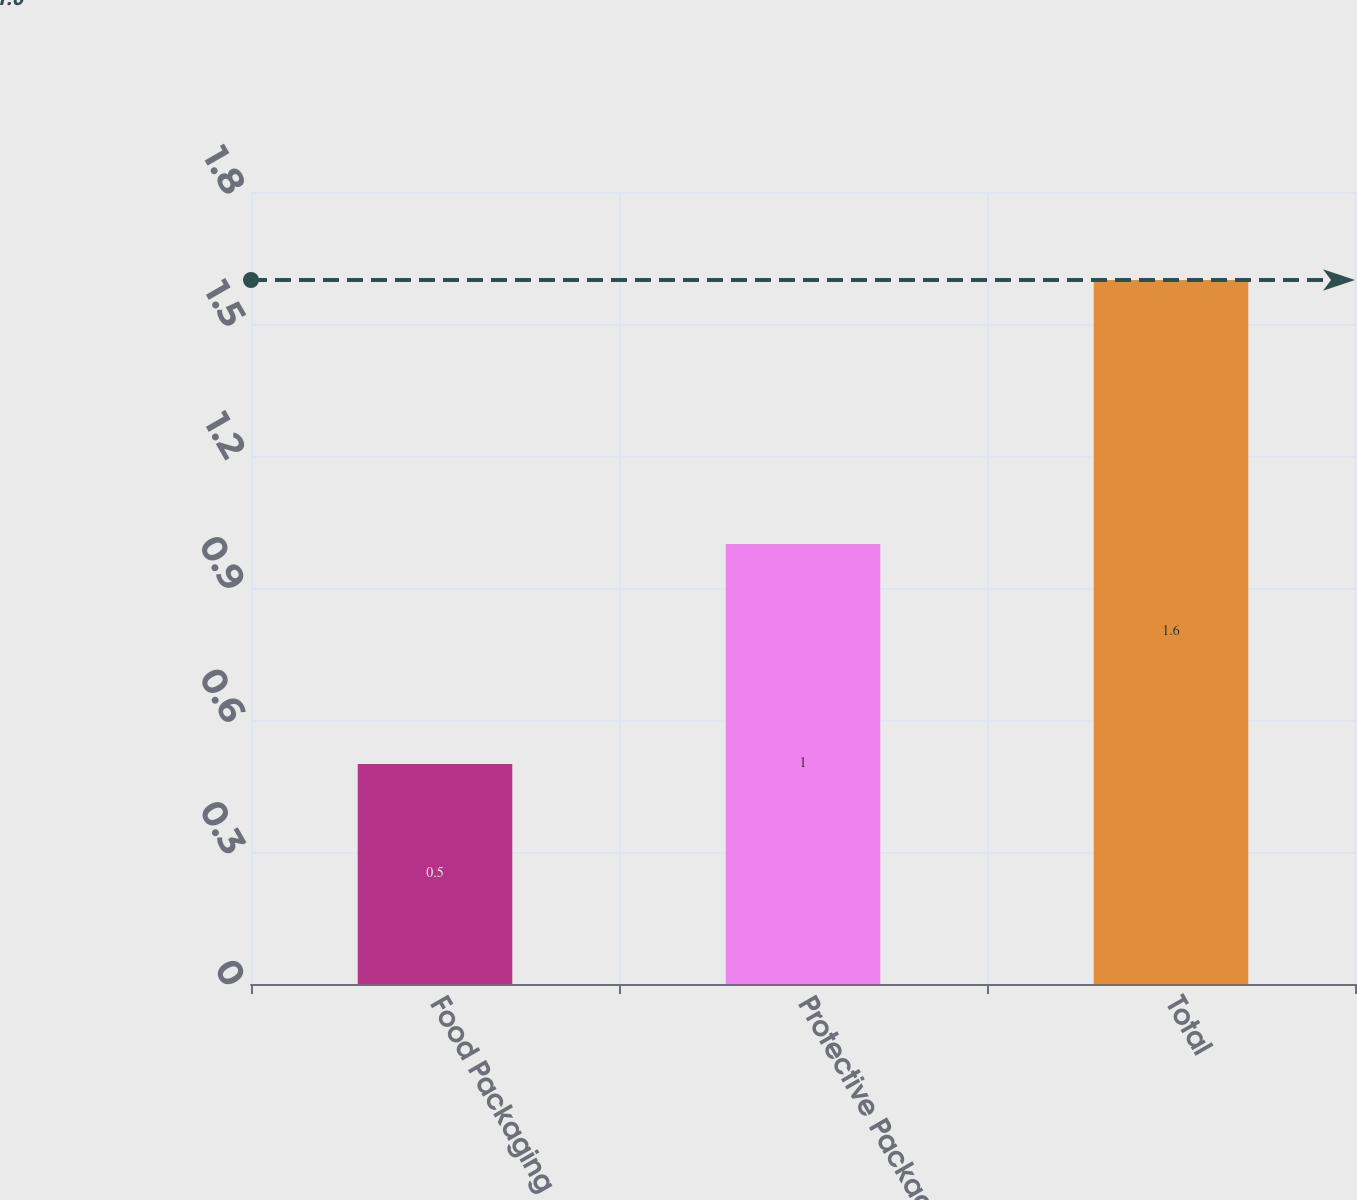Convert chart. <chart><loc_0><loc_0><loc_500><loc_500><bar_chart><fcel>Food Packaging<fcel>Protective Packaging<fcel>Total<nl><fcel>0.5<fcel>1<fcel>1.6<nl></chart> 